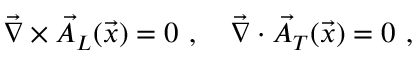Convert formula to latex. <formula><loc_0><loc_0><loc_500><loc_500>{ { \vec { \nabla } } } \times { \vec { A } } _ { L } ( { \vec { x } } ) = 0 , \quad { \vec { \nabla } } \cdot { \vec { A } } _ { T } ( { \vec { x } } ) = 0 ,</formula> 